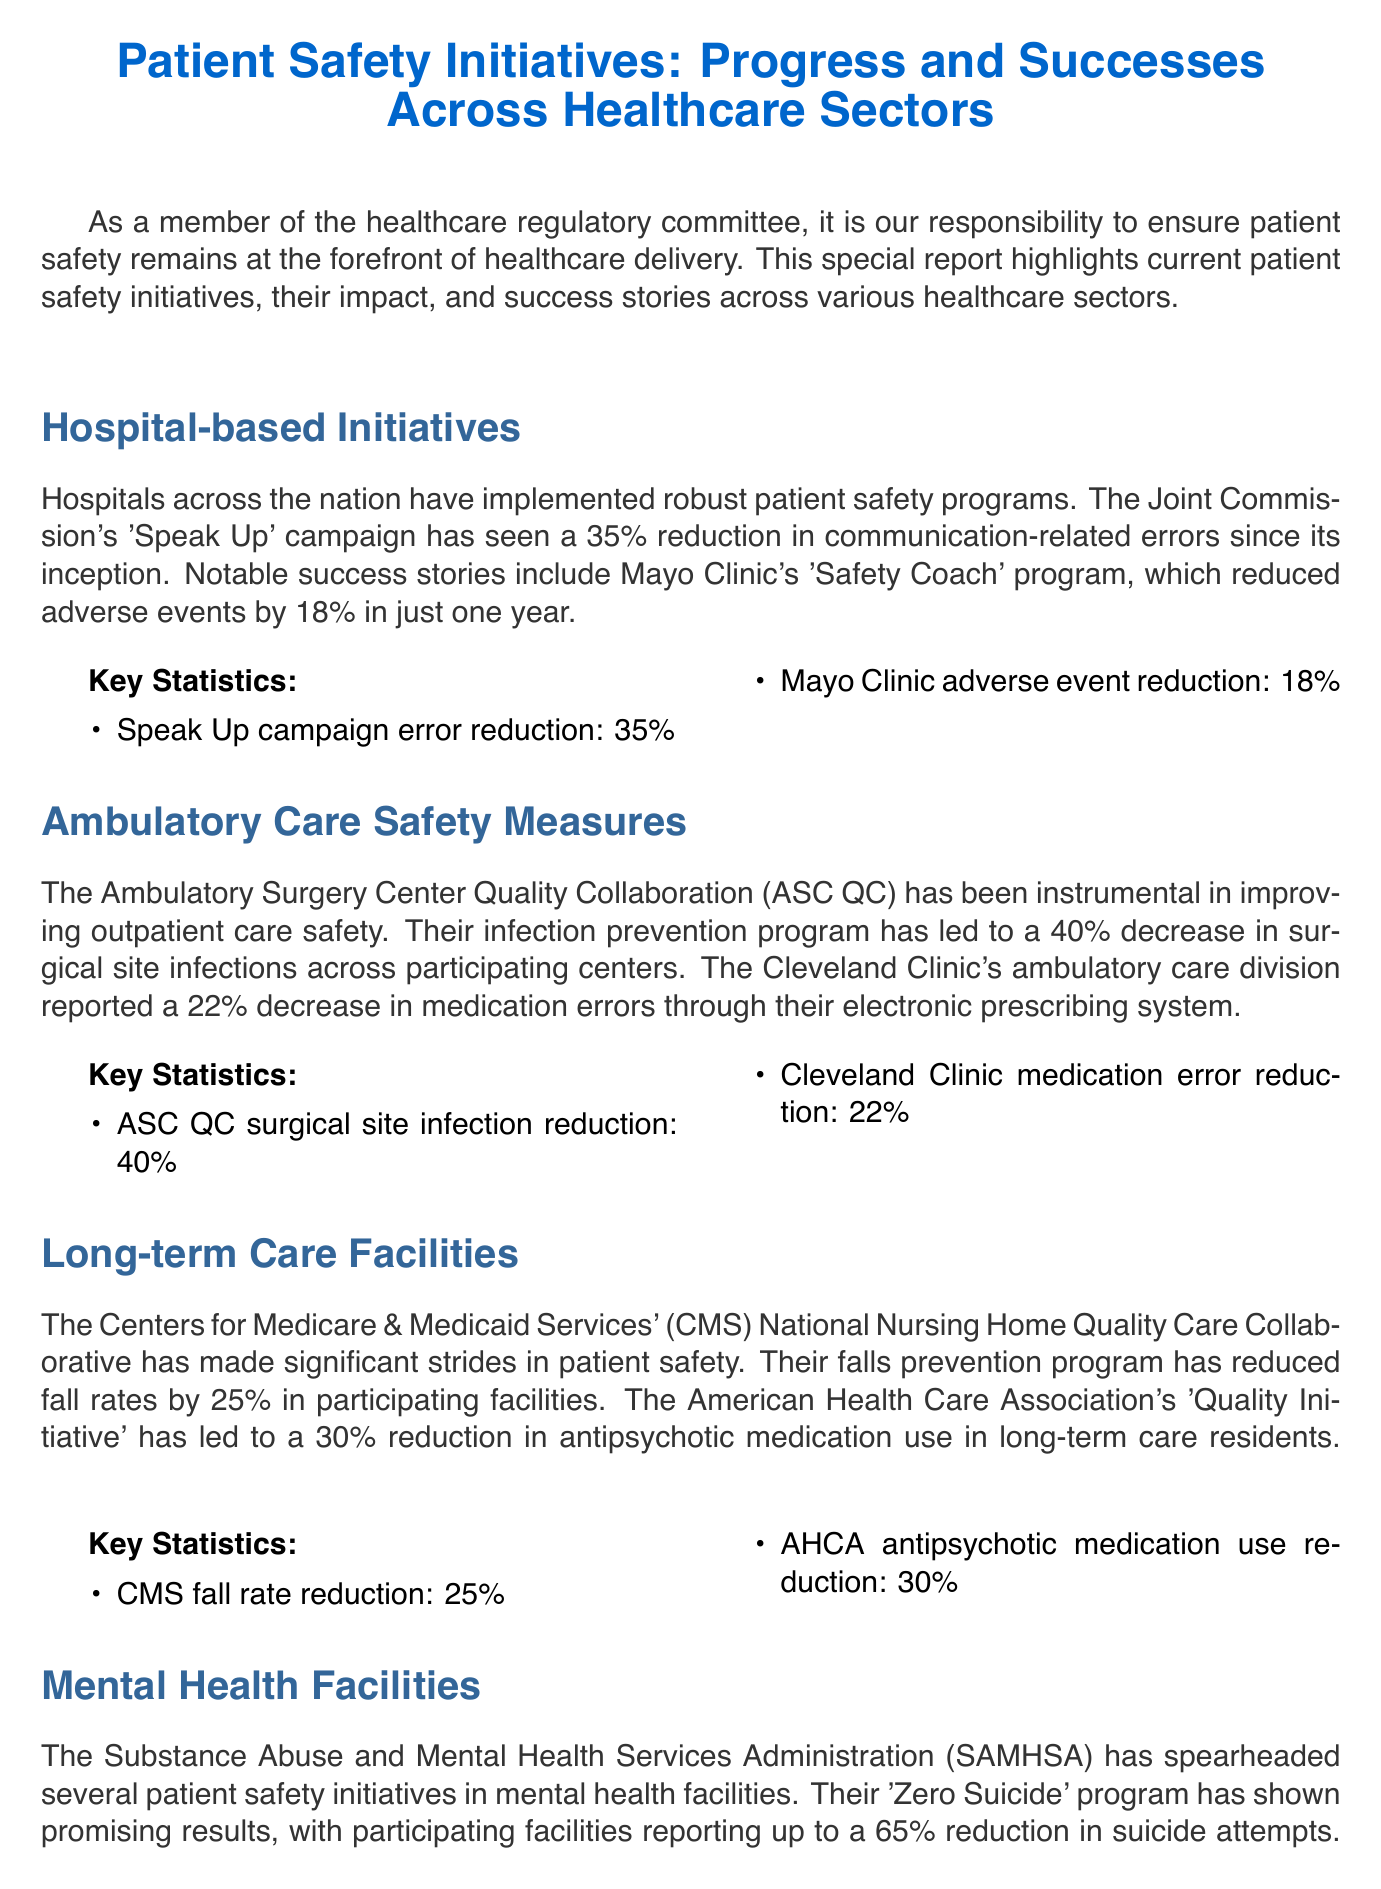What is the title of the newsletter? The title of the newsletter is presented at the beginning of the document to summarize the content.
Answer: Patient Safety Initiatives: Progress and Successes Across Healthcare Sectors What initiative reduced communication-related errors by 35%? The document specifically mentions the Joint Commission's campaign and its impact on communication errors.
Answer: Speak Up By what percentage did Mayo Clinic reduce adverse events? This statistic is highlighted as a notable success in the hospital-based initiatives section.
Answer: 18% What is the reduction rate of surgical site infections reported by ASC QC? The document discusses the impact of the ASC QC on surgical site infections, providing specific statistics.
Answer: 40% What was the percentage decrease in anti-psychotic medication use in long-term care residents? This information shows the success of the American Health Care Association's initiative in long-term care facilities.
Answer: 30% What program reported a 65% reduction in suicide attempts? The document highlights a specific program aimed at mental health facility improvements showcasing significant results.
Answer: Zero Suicide Which initiative led to a 15% reduction in severe allergic reactions? The statistic relates to post-market drug safety surveillance efforts mentioned in the pharmaceutical safety section.
Answer: FDA Sentinel Initiative What is the call to action for healthcare providers? The conclusion of the newsletter emphasizes the desired actions for healthcare providers moving forward.
Answer: Actively participate in these initiatives What type of care does the ASC QC focus on? The document categorizes ASC QC's role in the context of patient safety and care delivery.
Answer: Outpatient care 